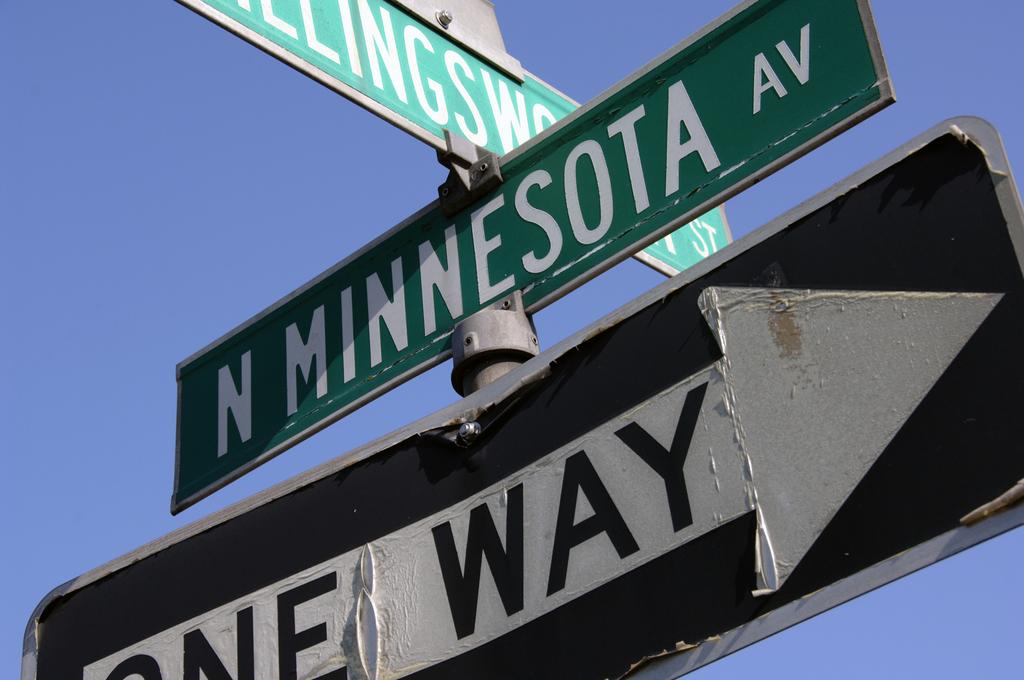How many way's can you go?
Ensure brevity in your answer.  One. 